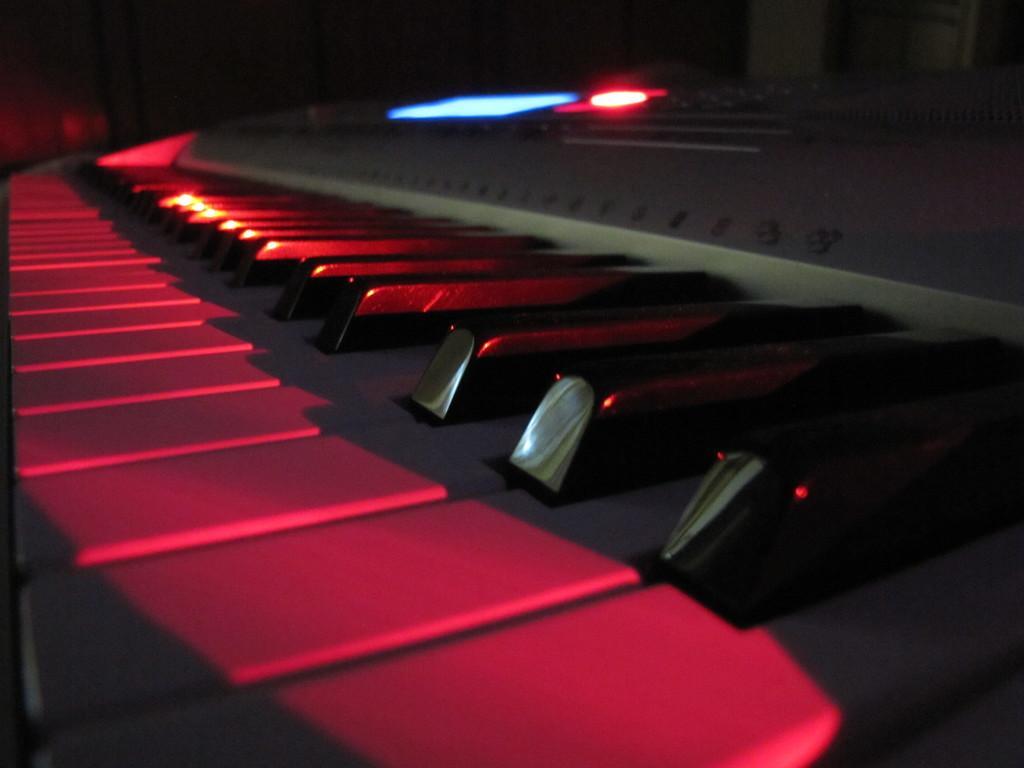Please provide a concise description of this image. In the above picture its a keyboard which is red and black in color. There is light glowing on it on the top of the key board which is in the middle of the picture and there is blue color screen small blue color screen which is beside the red color light in the above picture. There are number of keys on the keyboard in the above picture. 